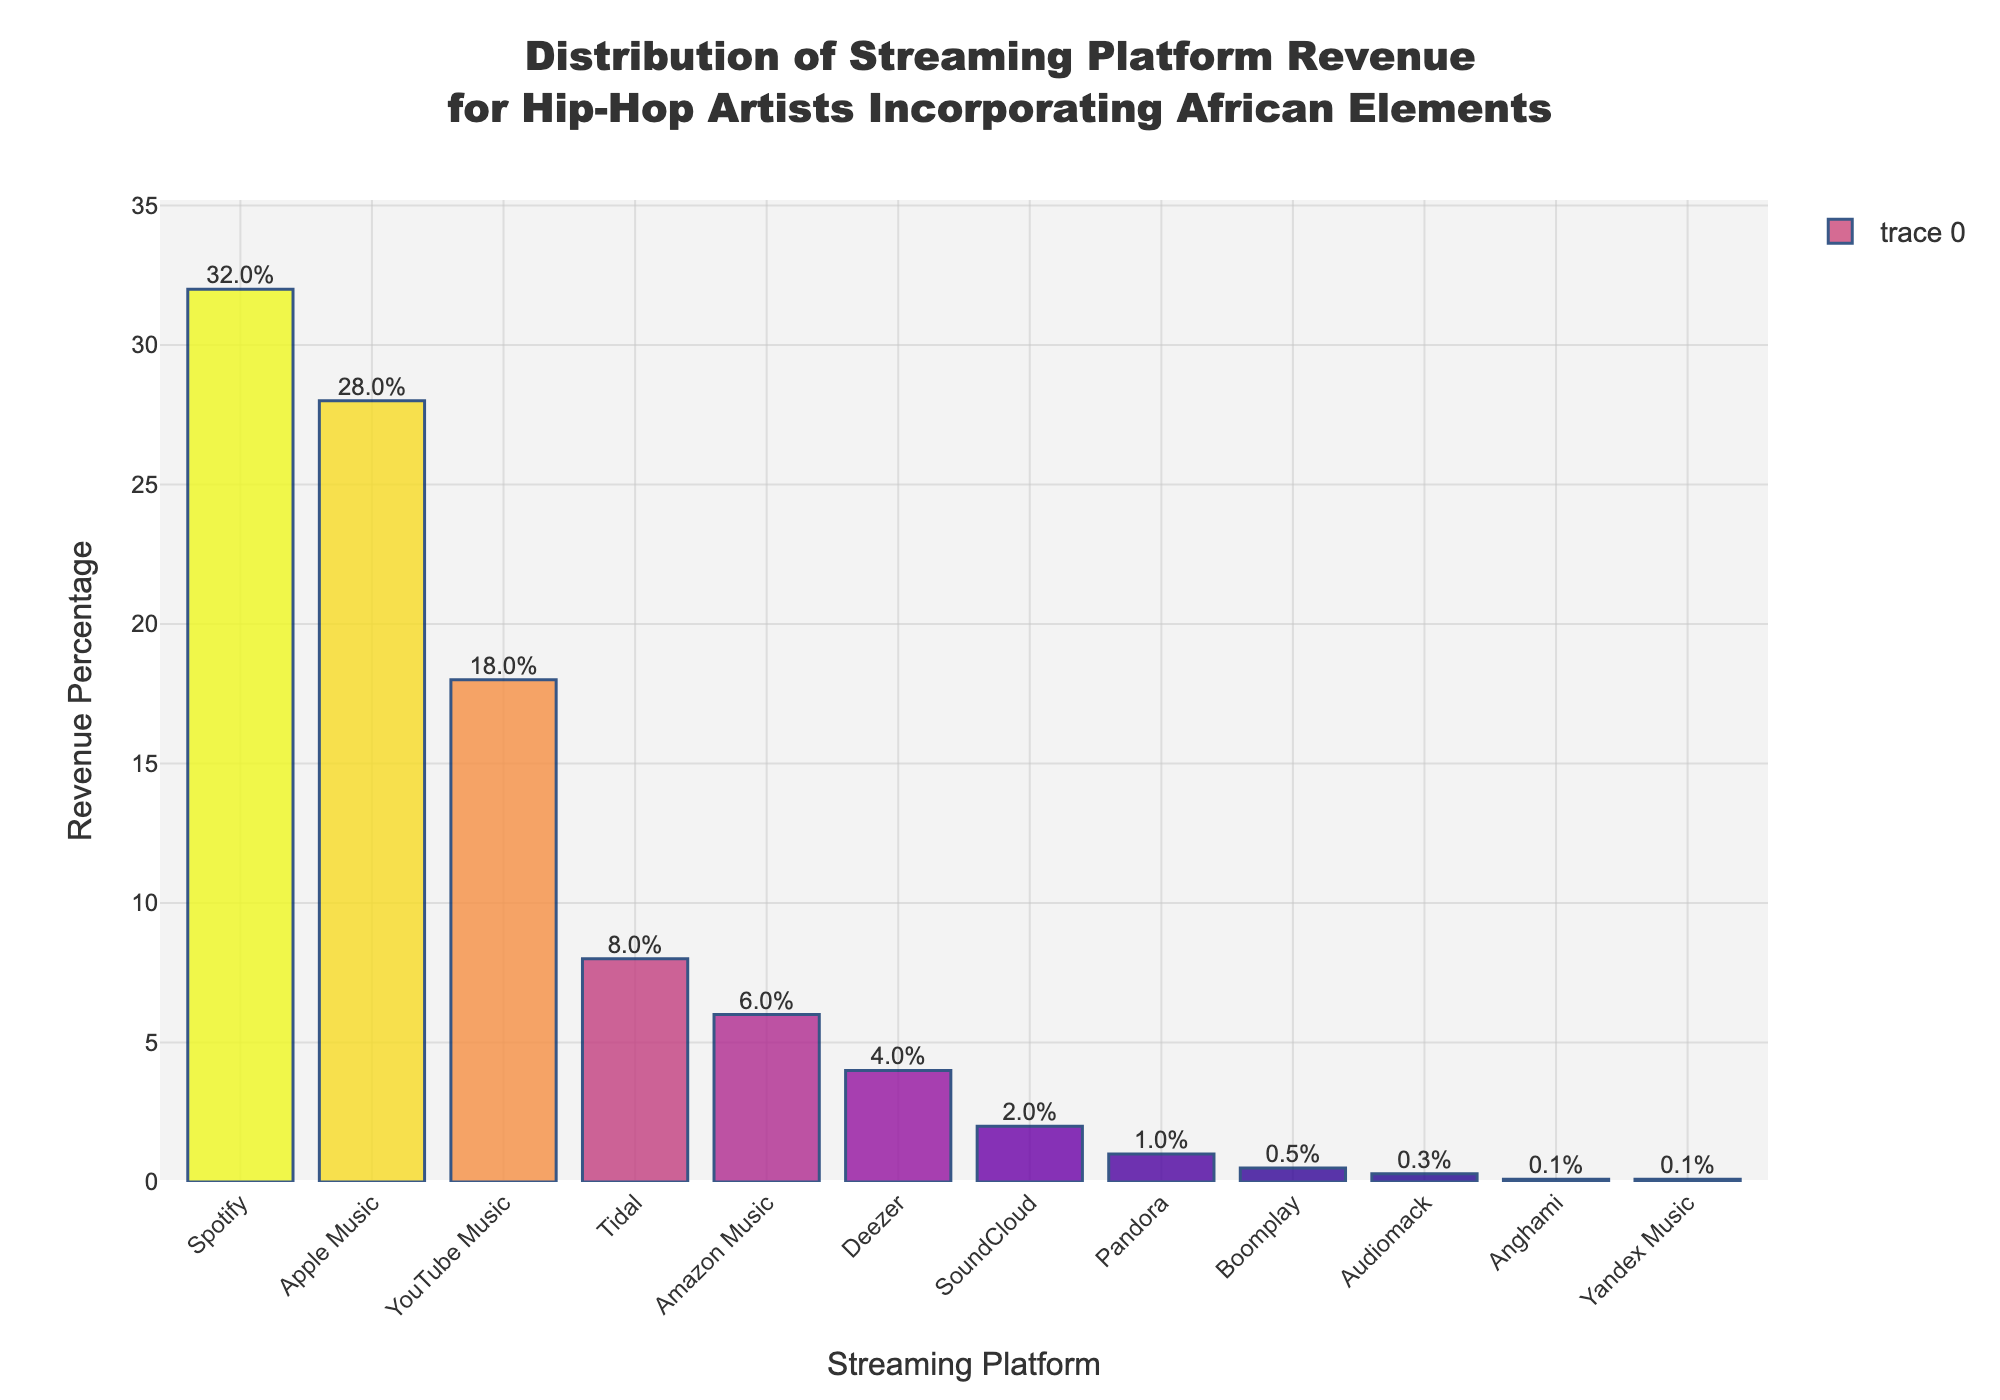Which streaming platform has the highest revenue percentage? By looking at the height of the bars and the labels on top, we see that Spotify has the tallest bar and has a label of 32%.
Answer: Spotify Which platform has the second-lowest revenue percentage? By looking at the height of the bars and their respective labels, we see that Anghami and Yandex Music both have a revenue percentage of 0.1%, which is the lowest. The next lowest bar is Audiomack with a percentage of 0.3%.
Answer: Audiomack What is the combined revenue percentage of YouTube Music and Tidal? YouTube Music has a revenue percentage of 18% and Tidal has a revenue percentage of 8%. Adding these together, 18% + 8% = 26%.
Answer: 26% Is the revenue percentage for Apple Music greater than that of YouTube Music? By comparing the height of the bars and their labels, Apple Music has a revenue percentage of 28% whereas YouTube Music has 18%. Therefore, Apple Music's revenue percentage is greater.
Answer: Yes Which platforms make up less than 5% of the revenue, and what is their total contribution? The platforms with bars lower than 5% are Deezer (4%), SoundCloud (2%), Pandora (1%), Boomplay (0.5%), Audiomack (0.3%), Anghami (0.1%), and Yandex Music (0.1%). Summing these values, 4% + 2% + 1% + 0.5% + 0.3% + 0.1% + 0.1% = 8%.
Answer: Deezer, SoundCloud, Pandora, Boomplay, Audiomack, Anghami, Yandex Music; 8% What is the difference in revenue percentage between Spotify and Amazon Music? Spotify has a revenue percentage of 32% and Amazon Music has 6%. Subtracting these, 32% - 6% = 26%.
Answer: 26% What is the average revenue percentage for the top 3 streaming platforms? The top 3 platforms are Spotify (32%), Apple Music (28%), and YouTube Music (18%). The average is calculated as (32 + 28 + 18) / 3 = 26%.
Answer: 26% Which platform has a revenue percentage closest to the median value of the dataset? First, sort the revenue percentages in ascending order and find the median. Using the sorted values (0.1, 0.1, 0.3, 0.5, 1, 2, 4, 6, 8, 18, 28, 32), the median is the middle value of the sorted list, which is (4 + 6) / 2 = 5%. The closest platform to 5% is Amazon Music with 6%.
Answer: Amazon Music Does any streaming platform have a revenue percentage equal to 10%? By examining the labels for all bars, no platform has a revenue percentage equal to 10%.
Answer: No What is the total revenue percentage represented by all streaming platforms on the chart? Adding the revenue percentages of all platforms: 32% + 28% + 18% + 8% + 6% + 4% + 2% + 1% + 0.5% + 0.3% + 0.1% + 0.1% = 100%.
Answer: 100% 